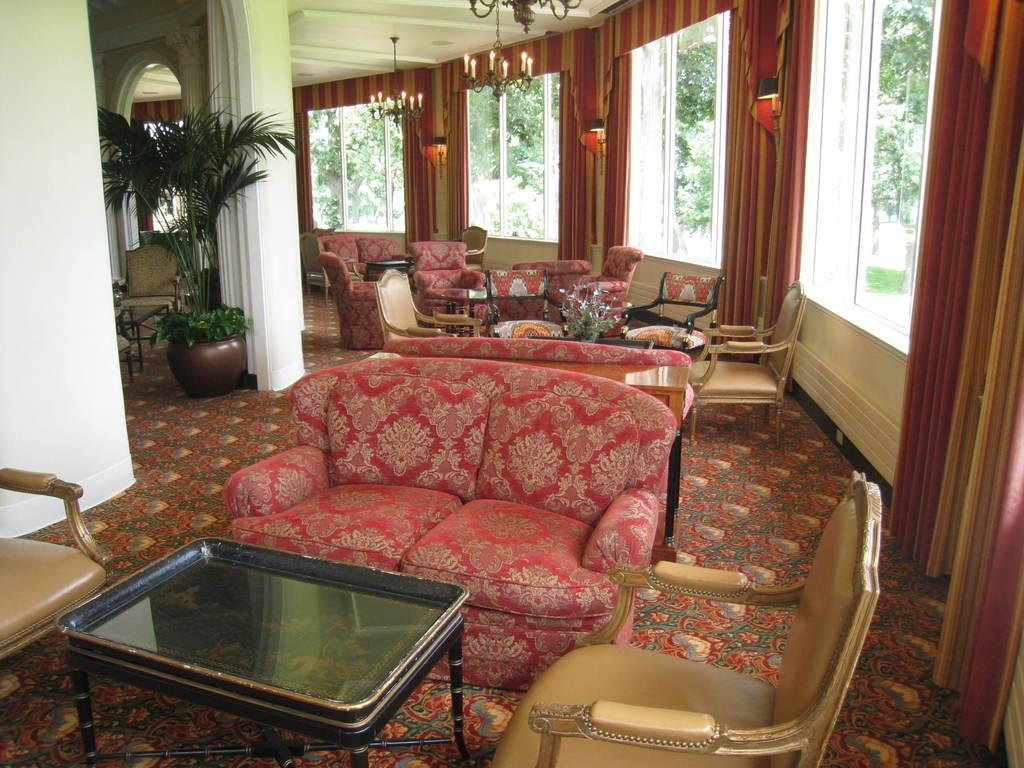What color is the wall in the image? The wall in the image is white. What can be seen on the wall? There is a plant in the image. What is visible through the window in the image? There are trees visible outside the window. What objects are present outside the window? There are sofas, chairs, and a table outside the window. What type of lighting is present in the image? There are candles in the image. What type of sock is hanging on the wall in the image? There is no sock present in the image; the wall has a plant on it. 